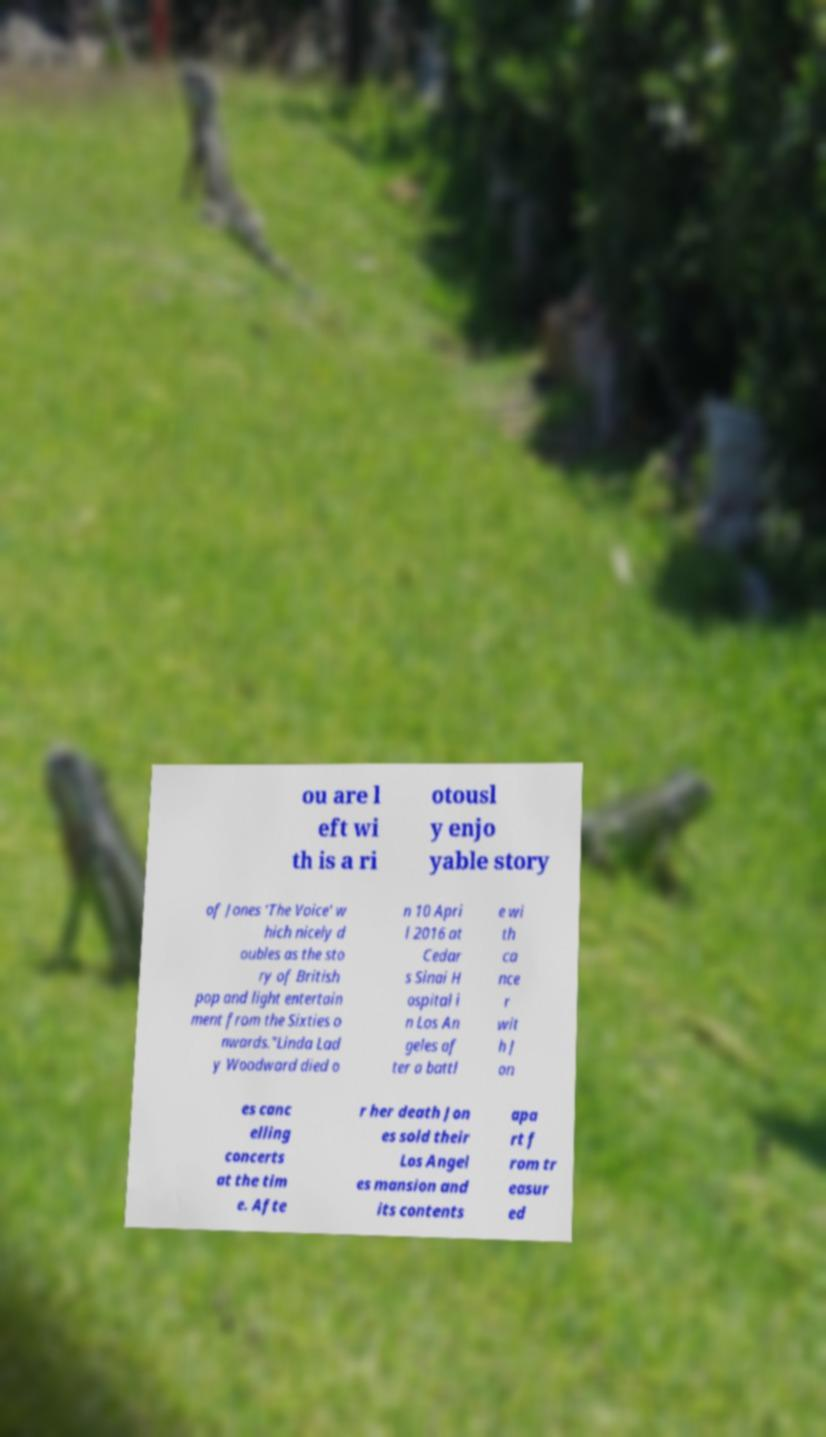Can you accurately transcribe the text from the provided image for me? ou are l eft wi th is a ri otousl y enjo yable story of Jones 'The Voice' w hich nicely d oubles as the sto ry of British pop and light entertain ment from the Sixties o nwards."Linda Lad y Woodward died o n 10 Apri l 2016 at Cedar s Sinai H ospital i n Los An geles af ter a battl e wi th ca nce r wit h J on es canc elling concerts at the tim e. Afte r her death Jon es sold their Los Angel es mansion and its contents apa rt f rom tr easur ed 